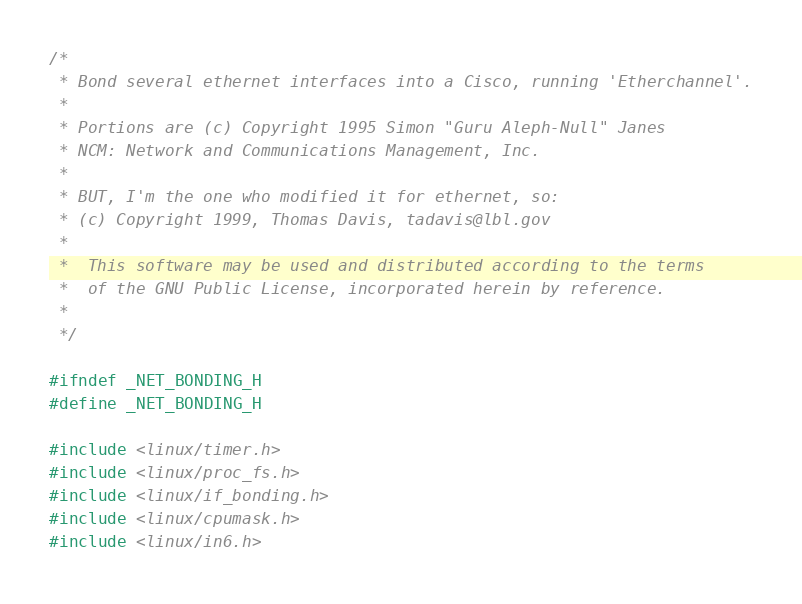<code> <loc_0><loc_0><loc_500><loc_500><_C_>/*
 * Bond several ethernet interfaces into a Cisco, running 'Etherchannel'.
 *
 * Portions are (c) Copyright 1995 Simon "Guru Aleph-Null" Janes
 * NCM: Network and Communications Management, Inc.
 *
 * BUT, I'm the one who modified it for ethernet, so:
 * (c) Copyright 1999, Thomas Davis, tadavis@lbl.gov
 *
 *	This software may be used and distributed according to the terms
 *	of the GNU Public License, incorporated herein by reference.
 *
 */

#ifndef _NET_BONDING_H
#define _NET_BONDING_H

#include <linux/timer.h>
#include <linux/proc_fs.h>
#include <linux/if_bonding.h>
#include <linux/cpumask.h>
#include <linux/in6.h></code> 